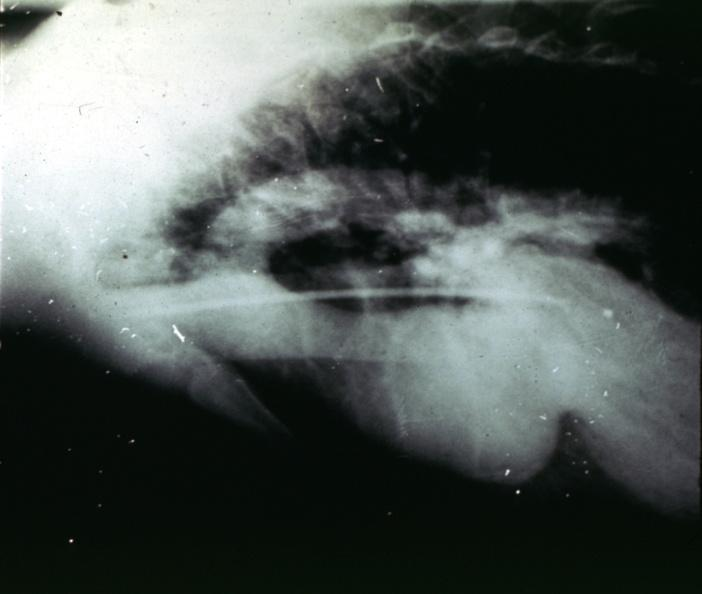where is this from?
Answer the question using a single word or phrase. Aorta 